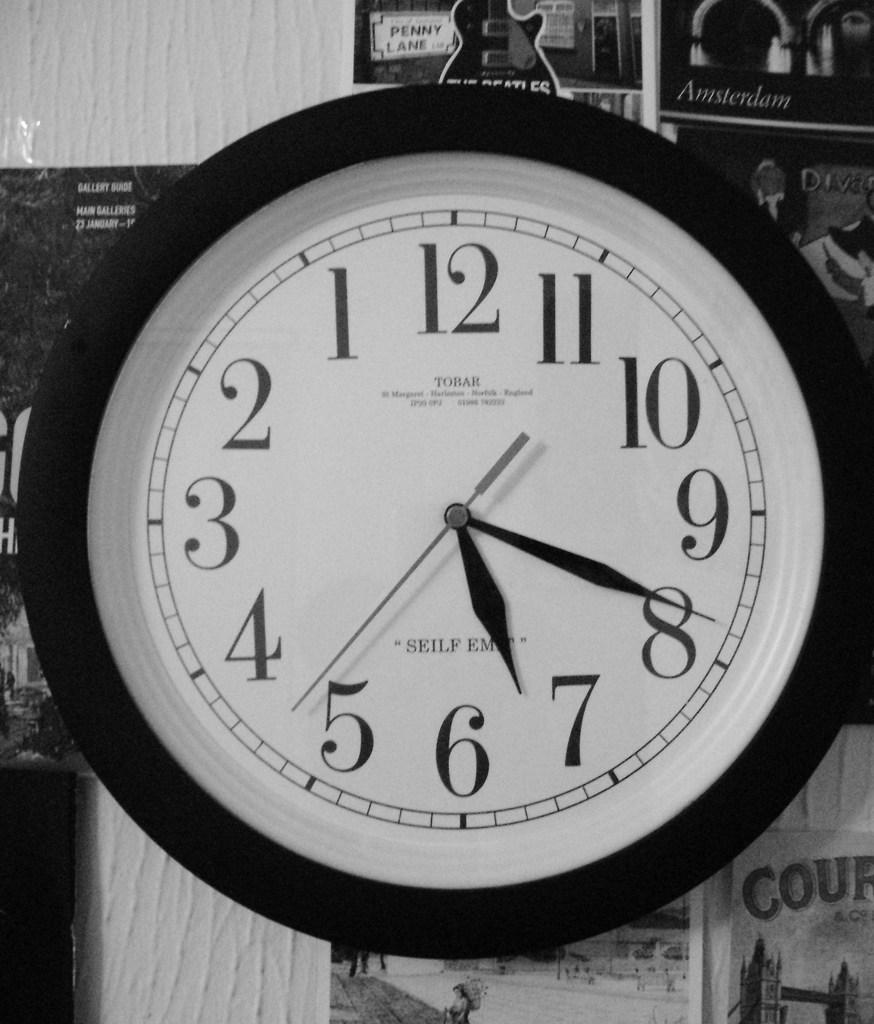<image>
Write a terse but informative summary of the picture. A Tobar clock shows the time as 7:40 in this black and white photo. 